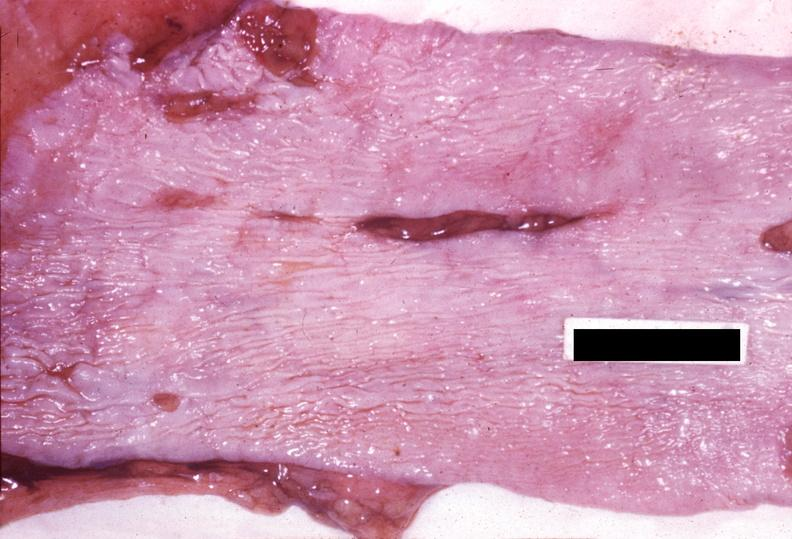does this image show esophagus, mallory-weiss tears?
Answer the question using a single word or phrase. Yes 